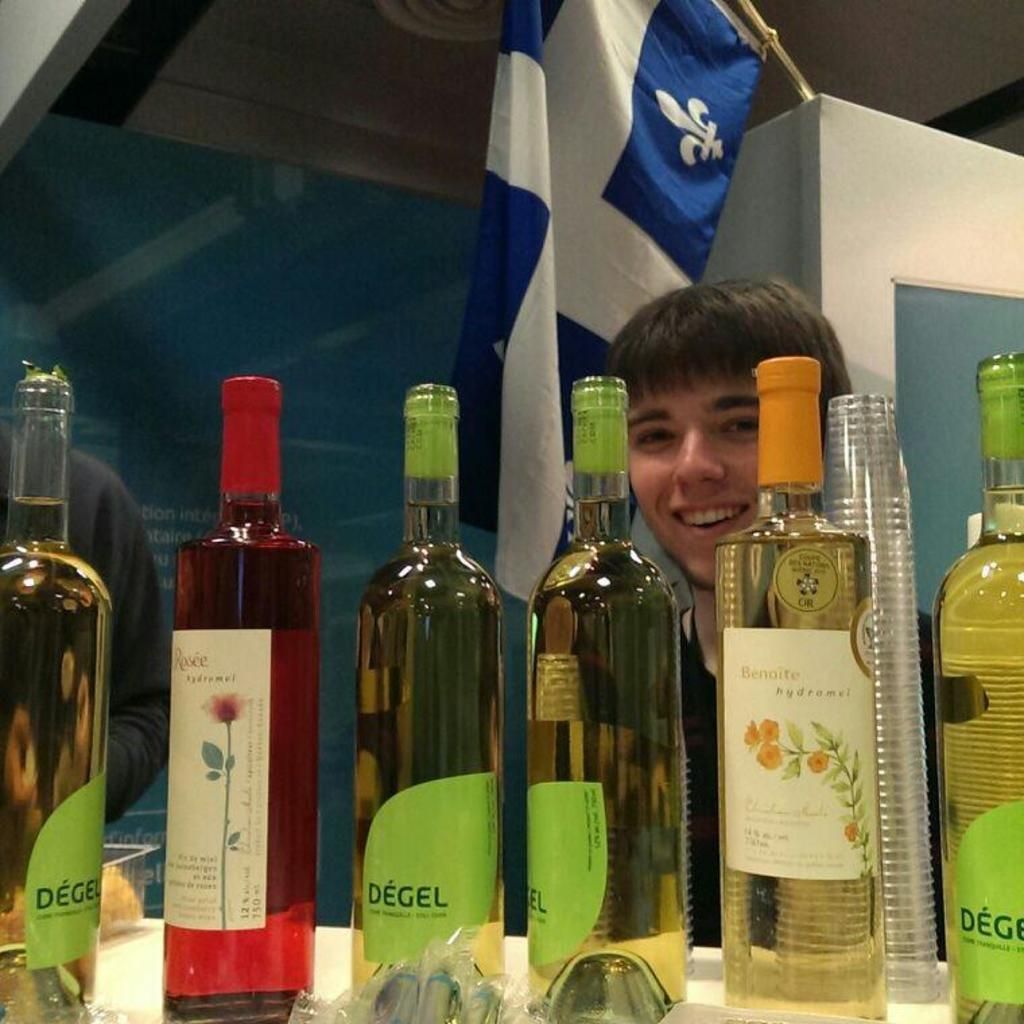Provide a one-sentence caption for the provided image. Several bottles of Degel have green labels on them. 